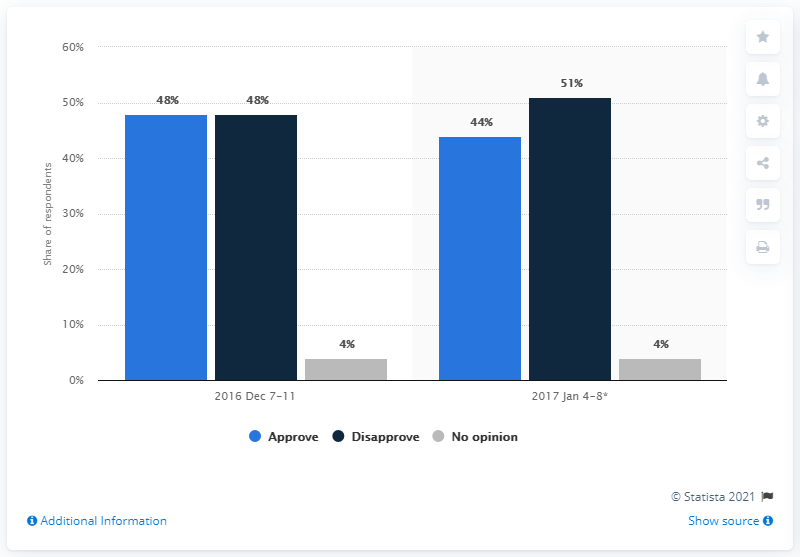Point out several critical features in this image. The graph shows the same percentage of people with other opinions as the one in the previous table. In 2017, the difference between approval and disapproval was significant. 